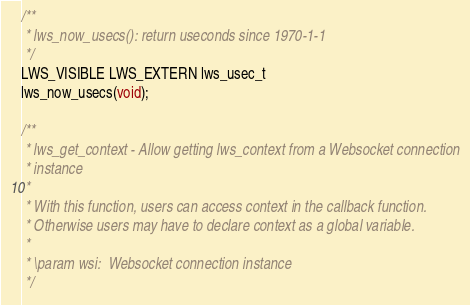<code> <loc_0><loc_0><loc_500><loc_500><_C_>
/**
 * lws_now_usecs(): return useconds since 1970-1-1
 */
LWS_VISIBLE LWS_EXTERN lws_usec_t
lws_now_usecs(void);

/**
 * lws_get_context - Allow getting lws_context from a Websocket connection
 * instance
 *
 * With this function, users can access context in the callback function.
 * Otherwise users may have to declare context as a global variable.
 *
 * \param wsi:	Websocket connection instance
 */</code> 